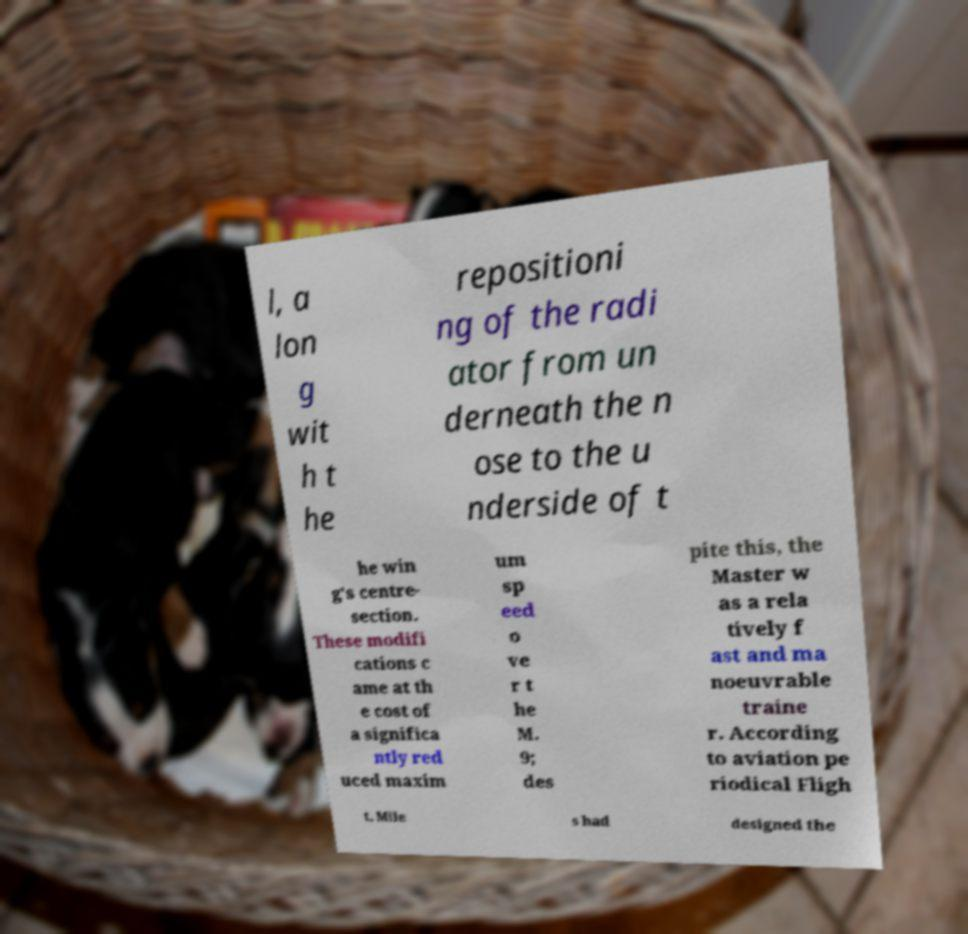Can you accurately transcribe the text from the provided image for me? l, a lon g wit h t he repositioni ng of the radi ator from un derneath the n ose to the u nderside of t he win g's centre- section. These modifi cations c ame at th e cost of a significa ntly red uced maxim um sp eed o ve r t he M. 9; des pite this, the Master w as a rela tively f ast and ma noeuvrable traine r. According to aviation pe riodical Fligh t, Mile s had designed the 